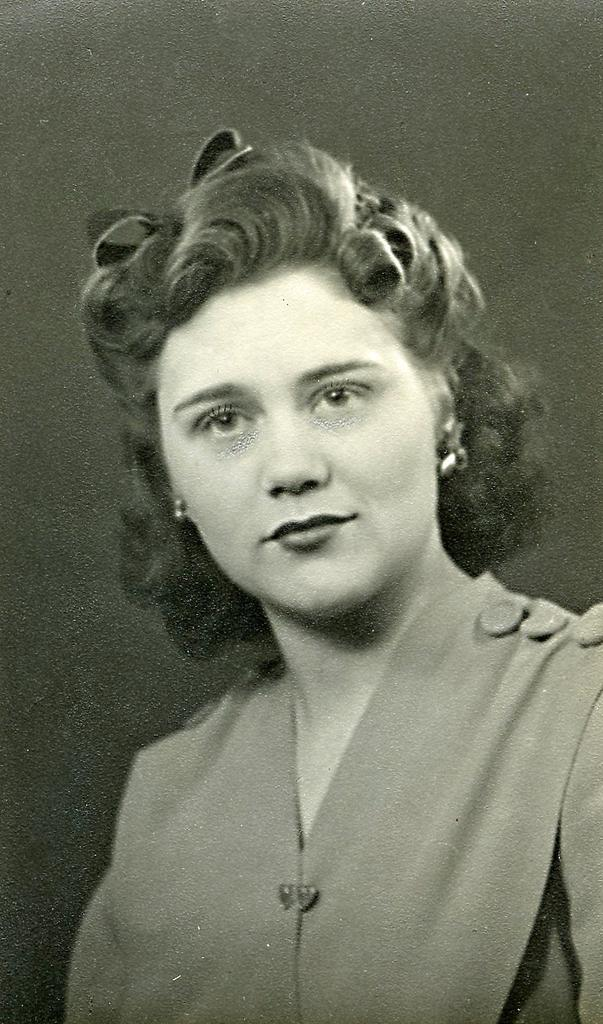Who is the main subject in the image? There is a lady in the image. What is the color scheme of the image? The image is in black and white color. What type of work is the lady doing in the image? There is no indication of any work being done in the image, as it only shows a lady in black and white. Can you see any pests in the image? There are no pests visible in the image; it only features a lady in black and white. 